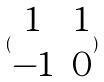<formula> <loc_0><loc_0><loc_500><loc_500>( \begin{matrix} 1 & 1 \\ - 1 & 0 \end{matrix} )</formula> 